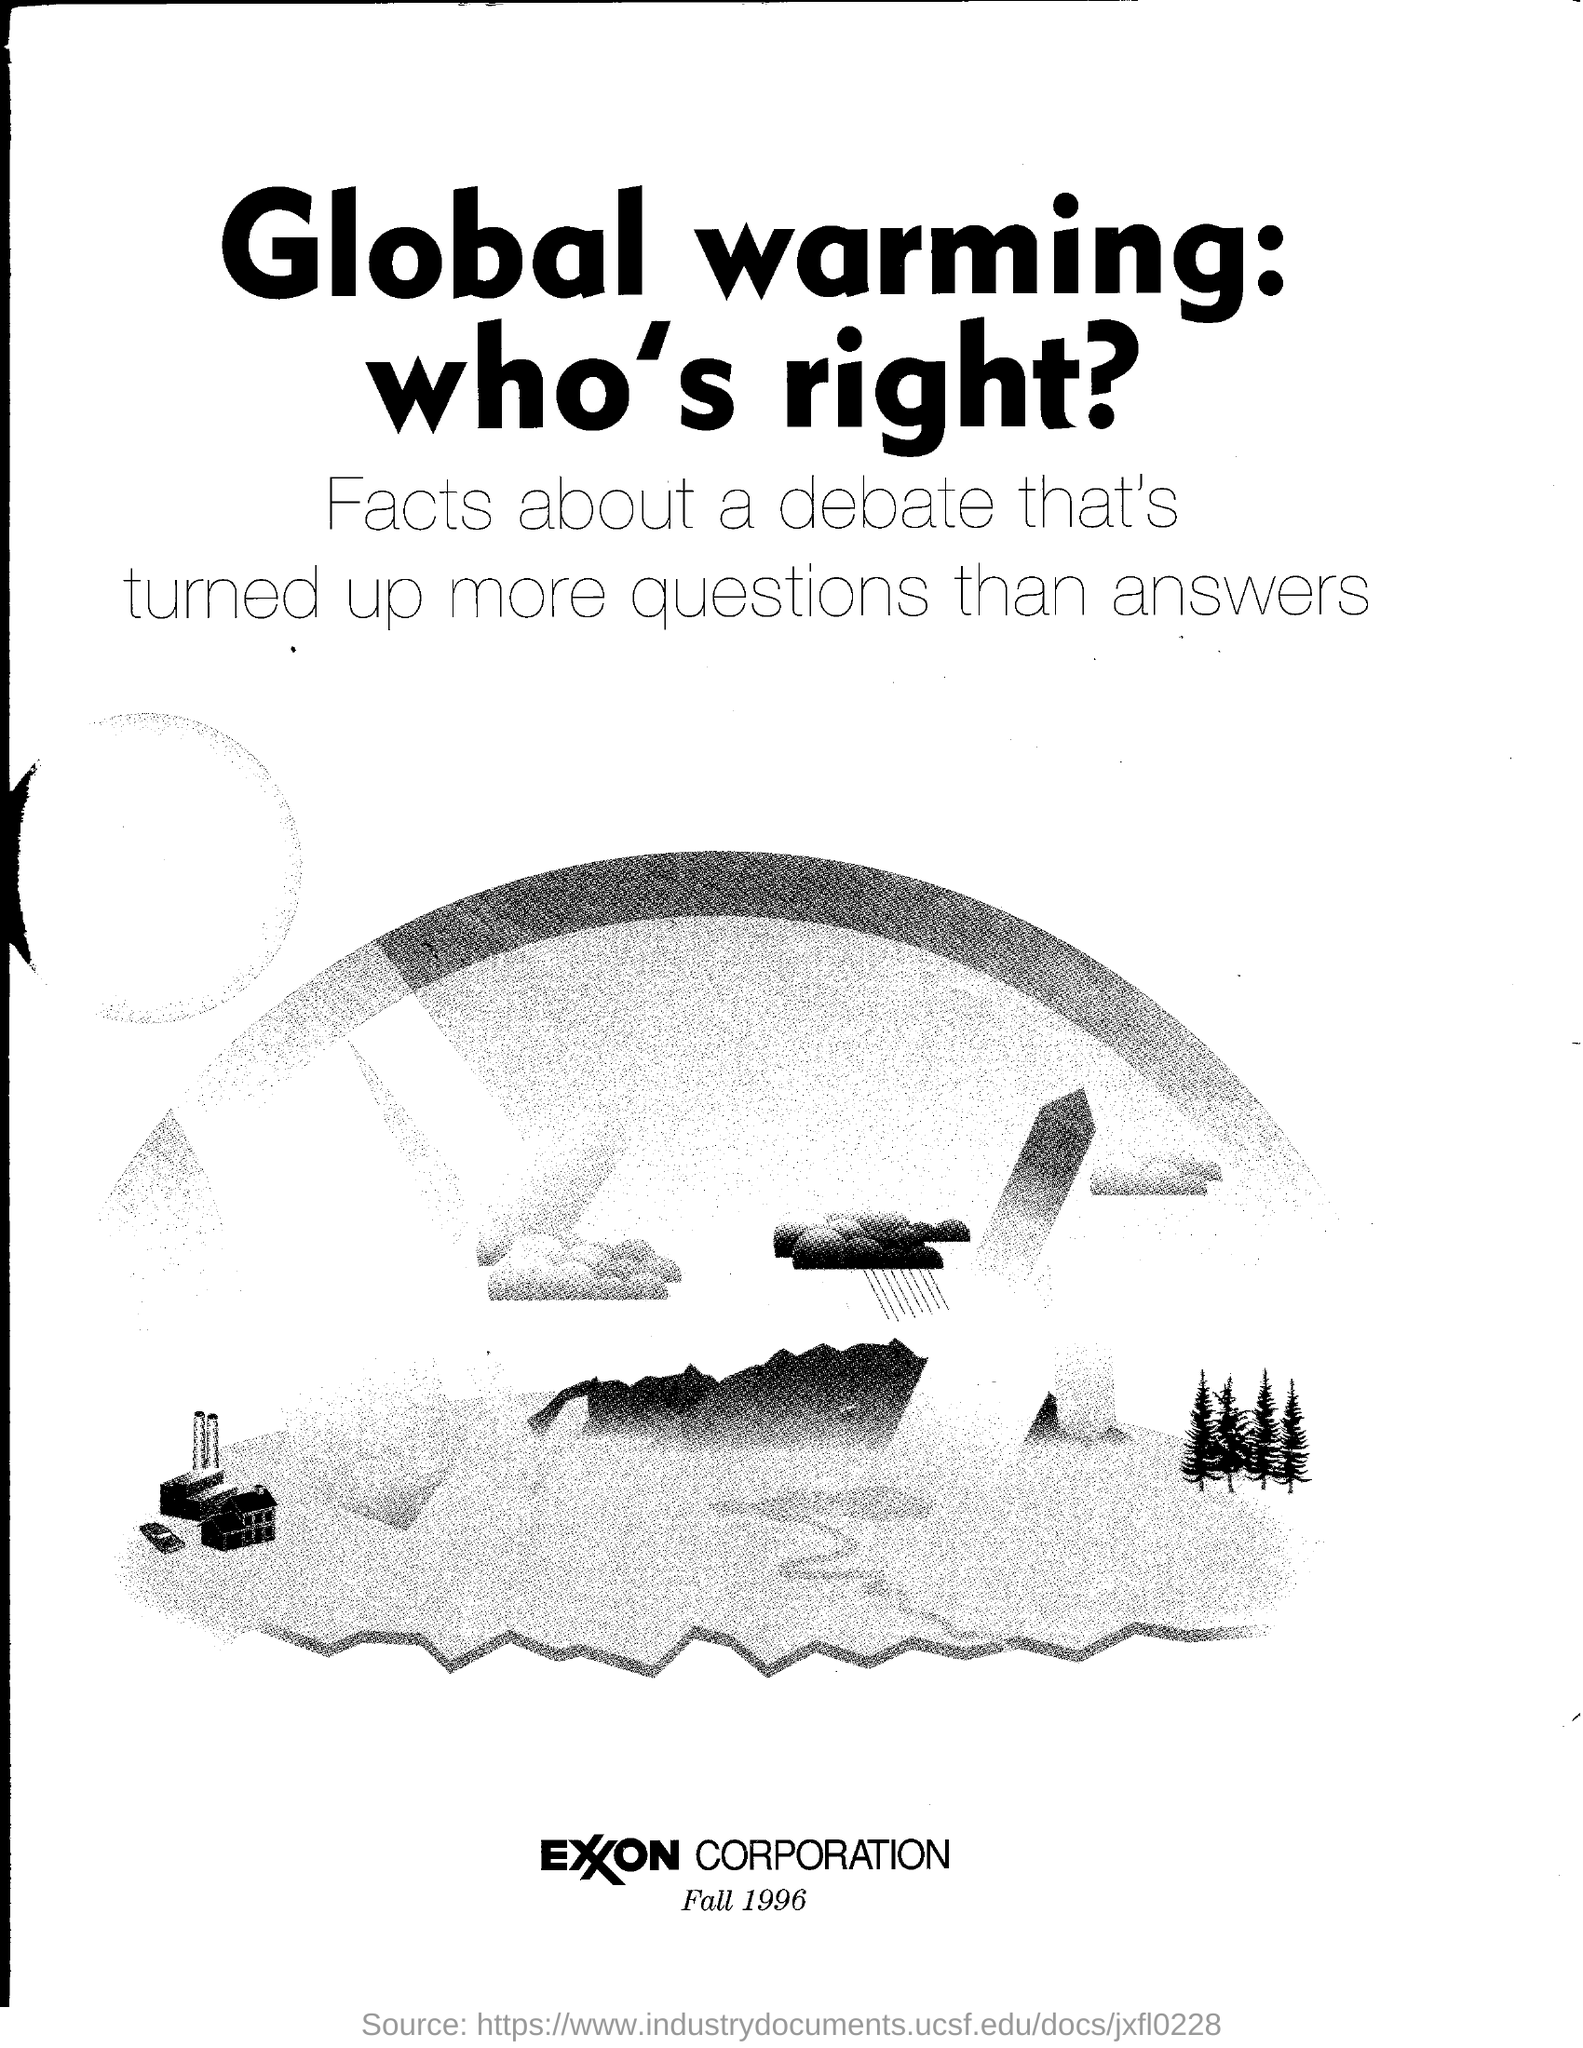Which year is given?
Your response must be concise. 1996. 